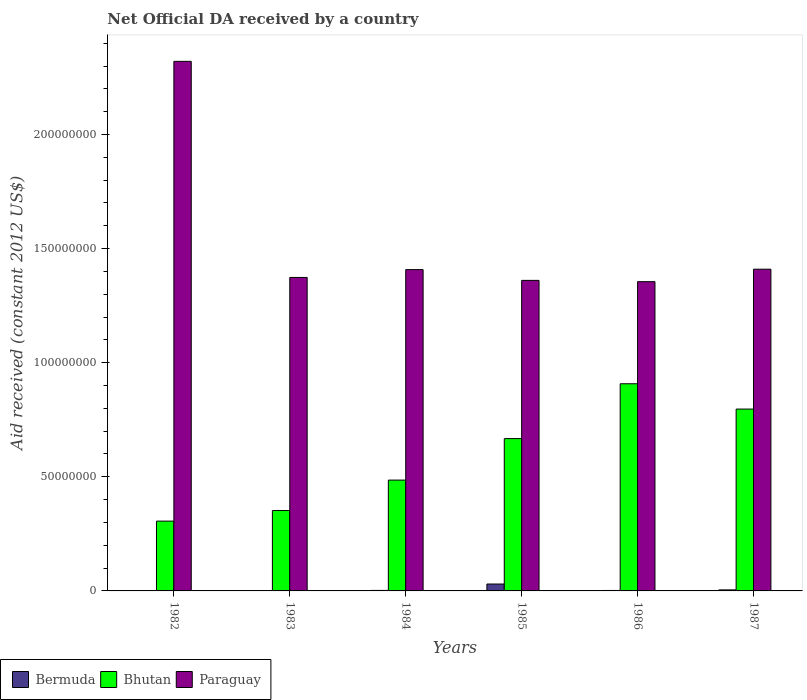How many different coloured bars are there?
Offer a very short reply. 3. How many groups of bars are there?
Provide a short and direct response. 6. Are the number of bars on each tick of the X-axis equal?
Offer a terse response. Yes. In how many cases, is the number of bars for a given year not equal to the number of legend labels?
Give a very brief answer. 0. What is the net official development assistance aid received in Paraguay in 1987?
Give a very brief answer. 1.41e+08. Across all years, what is the maximum net official development assistance aid received in Bermuda?
Offer a terse response. 3.02e+06. In which year was the net official development assistance aid received in Bermuda minimum?
Keep it short and to the point. 1982. What is the total net official development assistance aid received in Bermuda in the graph?
Provide a short and direct response. 4.25e+06. What is the difference between the net official development assistance aid received in Bhutan in 1983 and that in 1985?
Provide a succinct answer. -3.15e+07. What is the difference between the net official development assistance aid received in Bermuda in 1987 and the net official development assistance aid received in Bhutan in 1984?
Offer a terse response. -4.81e+07. What is the average net official development assistance aid received in Bermuda per year?
Offer a terse response. 7.08e+05. In the year 1984, what is the difference between the net official development assistance aid received in Bermuda and net official development assistance aid received in Bhutan?
Your response must be concise. -4.83e+07. What is the ratio of the net official development assistance aid received in Paraguay in 1983 to that in 1985?
Keep it short and to the point. 1.01. Is the net official development assistance aid received in Bhutan in 1982 less than that in 1987?
Ensure brevity in your answer.  Yes. Is the difference between the net official development assistance aid received in Bermuda in 1982 and 1985 greater than the difference between the net official development assistance aid received in Bhutan in 1982 and 1985?
Offer a very short reply. Yes. What is the difference between the highest and the second highest net official development assistance aid received in Bermuda?
Provide a short and direct response. 2.57e+06. What is the difference between the highest and the lowest net official development assistance aid received in Paraguay?
Offer a terse response. 9.65e+07. In how many years, is the net official development assistance aid received in Bhutan greater than the average net official development assistance aid received in Bhutan taken over all years?
Make the answer very short. 3. Is the sum of the net official development assistance aid received in Bhutan in 1985 and 1986 greater than the maximum net official development assistance aid received in Bermuda across all years?
Offer a very short reply. Yes. What does the 3rd bar from the left in 1982 represents?
Offer a terse response. Paraguay. What does the 2nd bar from the right in 1986 represents?
Keep it short and to the point. Bhutan. Are all the bars in the graph horizontal?
Your answer should be very brief. No. What is the difference between two consecutive major ticks on the Y-axis?
Ensure brevity in your answer.  5.00e+07. Does the graph contain grids?
Provide a short and direct response. No. How many legend labels are there?
Give a very brief answer. 3. How are the legend labels stacked?
Provide a succinct answer. Horizontal. What is the title of the graph?
Keep it short and to the point. Net Official DA received by a country. What is the label or title of the X-axis?
Provide a short and direct response. Years. What is the label or title of the Y-axis?
Ensure brevity in your answer.  Aid received (constant 2012 US$). What is the Aid received (constant 2012 US$) of Bermuda in 1982?
Keep it short and to the point. 1.80e+05. What is the Aid received (constant 2012 US$) in Bhutan in 1982?
Make the answer very short. 3.06e+07. What is the Aid received (constant 2012 US$) of Paraguay in 1982?
Your answer should be very brief. 2.32e+08. What is the Aid received (constant 2012 US$) of Bermuda in 1983?
Your answer should be very brief. 1.80e+05. What is the Aid received (constant 2012 US$) in Bhutan in 1983?
Your response must be concise. 3.52e+07. What is the Aid received (constant 2012 US$) in Paraguay in 1983?
Ensure brevity in your answer.  1.37e+08. What is the Aid received (constant 2012 US$) in Bhutan in 1984?
Offer a terse response. 4.86e+07. What is the Aid received (constant 2012 US$) in Paraguay in 1984?
Keep it short and to the point. 1.41e+08. What is the Aid received (constant 2012 US$) of Bermuda in 1985?
Your answer should be very brief. 3.02e+06. What is the Aid received (constant 2012 US$) in Bhutan in 1985?
Provide a succinct answer. 6.68e+07. What is the Aid received (constant 2012 US$) of Paraguay in 1985?
Give a very brief answer. 1.36e+08. What is the Aid received (constant 2012 US$) of Bermuda in 1986?
Ensure brevity in your answer.  2.00e+05. What is the Aid received (constant 2012 US$) of Bhutan in 1986?
Provide a short and direct response. 9.08e+07. What is the Aid received (constant 2012 US$) in Paraguay in 1986?
Provide a short and direct response. 1.36e+08. What is the Aid received (constant 2012 US$) in Bermuda in 1987?
Your answer should be very brief. 4.50e+05. What is the Aid received (constant 2012 US$) in Bhutan in 1987?
Offer a very short reply. 7.97e+07. What is the Aid received (constant 2012 US$) of Paraguay in 1987?
Give a very brief answer. 1.41e+08. Across all years, what is the maximum Aid received (constant 2012 US$) in Bermuda?
Your answer should be compact. 3.02e+06. Across all years, what is the maximum Aid received (constant 2012 US$) of Bhutan?
Make the answer very short. 9.08e+07. Across all years, what is the maximum Aid received (constant 2012 US$) in Paraguay?
Offer a terse response. 2.32e+08. Across all years, what is the minimum Aid received (constant 2012 US$) of Bermuda?
Your answer should be very brief. 1.80e+05. Across all years, what is the minimum Aid received (constant 2012 US$) in Bhutan?
Your answer should be very brief. 3.06e+07. Across all years, what is the minimum Aid received (constant 2012 US$) of Paraguay?
Your answer should be very brief. 1.36e+08. What is the total Aid received (constant 2012 US$) in Bermuda in the graph?
Your response must be concise. 4.25e+06. What is the total Aid received (constant 2012 US$) in Bhutan in the graph?
Your answer should be compact. 3.52e+08. What is the total Aid received (constant 2012 US$) in Paraguay in the graph?
Provide a short and direct response. 9.23e+08. What is the difference between the Aid received (constant 2012 US$) of Bermuda in 1982 and that in 1983?
Give a very brief answer. 0. What is the difference between the Aid received (constant 2012 US$) in Bhutan in 1982 and that in 1983?
Provide a short and direct response. -4.64e+06. What is the difference between the Aid received (constant 2012 US$) in Paraguay in 1982 and that in 1983?
Keep it short and to the point. 9.47e+07. What is the difference between the Aid received (constant 2012 US$) of Bhutan in 1982 and that in 1984?
Make the answer very short. -1.80e+07. What is the difference between the Aid received (constant 2012 US$) in Paraguay in 1982 and that in 1984?
Your response must be concise. 9.13e+07. What is the difference between the Aid received (constant 2012 US$) of Bermuda in 1982 and that in 1985?
Your response must be concise. -2.84e+06. What is the difference between the Aid received (constant 2012 US$) in Bhutan in 1982 and that in 1985?
Provide a short and direct response. -3.62e+07. What is the difference between the Aid received (constant 2012 US$) of Paraguay in 1982 and that in 1985?
Provide a short and direct response. 9.60e+07. What is the difference between the Aid received (constant 2012 US$) of Bermuda in 1982 and that in 1986?
Your response must be concise. -2.00e+04. What is the difference between the Aid received (constant 2012 US$) in Bhutan in 1982 and that in 1986?
Your answer should be very brief. -6.02e+07. What is the difference between the Aid received (constant 2012 US$) in Paraguay in 1982 and that in 1986?
Make the answer very short. 9.65e+07. What is the difference between the Aid received (constant 2012 US$) of Bhutan in 1982 and that in 1987?
Provide a succinct answer. -4.91e+07. What is the difference between the Aid received (constant 2012 US$) in Paraguay in 1982 and that in 1987?
Provide a succinct answer. 9.11e+07. What is the difference between the Aid received (constant 2012 US$) in Bhutan in 1983 and that in 1984?
Keep it short and to the point. -1.33e+07. What is the difference between the Aid received (constant 2012 US$) in Paraguay in 1983 and that in 1984?
Your answer should be very brief. -3.43e+06. What is the difference between the Aid received (constant 2012 US$) in Bermuda in 1983 and that in 1985?
Your response must be concise. -2.84e+06. What is the difference between the Aid received (constant 2012 US$) in Bhutan in 1983 and that in 1985?
Provide a succinct answer. -3.15e+07. What is the difference between the Aid received (constant 2012 US$) in Paraguay in 1983 and that in 1985?
Give a very brief answer. 1.29e+06. What is the difference between the Aid received (constant 2012 US$) in Bhutan in 1983 and that in 1986?
Provide a short and direct response. -5.56e+07. What is the difference between the Aid received (constant 2012 US$) of Paraguay in 1983 and that in 1986?
Your answer should be compact. 1.85e+06. What is the difference between the Aid received (constant 2012 US$) of Bermuda in 1983 and that in 1987?
Offer a terse response. -2.70e+05. What is the difference between the Aid received (constant 2012 US$) in Bhutan in 1983 and that in 1987?
Provide a short and direct response. -4.45e+07. What is the difference between the Aid received (constant 2012 US$) of Paraguay in 1983 and that in 1987?
Your answer should be very brief. -3.61e+06. What is the difference between the Aid received (constant 2012 US$) in Bermuda in 1984 and that in 1985?
Give a very brief answer. -2.80e+06. What is the difference between the Aid received (constant 2012 US$) in Bhutan in 1984 and that in 1985?
Ensure brevity in your answer.  -1.82e+07. What is the difference between the Aid received (constant 2012 US$) in Paraguay in 1984 and that in 1985?
Provide a succinct answer. 4.72e+06. What is the difference between the Aid received (constant 2012 US$) of Bhutan in 1984 and that in 1986?
Your answer should be compact. -4.22e+07. What is the difference between the Aid received (constant 2012 US$) in Paraguay in 1984 and that in 1986?
Provide a succinct answer. 5.28e+06. What is the difference between the Aid received (constant 2012 US$) of Bhutan in 1984 and that in 1987?
Offer a very short reply. -3.11e+07. What is the difference between the Aid received (constant 2012 US$) in Bermuda in 1985 and that in 1986?
Give a very brief answer. 2.82e+06. What is the difference between the Aid received (constant 2012 US$) in Bhutan in 1985 and that in 1986?
Make the answer very short. -2.40e+07. What is the difference between the Aid received (constant 2012 US$) in Paraguay in 1985 and that in 1986?
Your response must be concise. 5.60e+05. What is the difference between the Aid received (constant 2012 US$) in Bermuda in 1985 and that in 1987?
Offer a terse response. 2.57e+06. What is the difference between the Aid received (constant 2012 US$) of Bhutan in 1985 and that in 1987?
Ensure brevity in your answer.  -1.29e+07. What is the difference between the Aid received (constant 2012 US$) of Paraguay in 1985 and that in 1987?
Your answer should be compact. -4.90e+06. What is the difference between the Aid received (constant 2012 US$) in Bhutan in 1986 and that in 1987?
Give a very brief answer. 1.11e+07. What is the difference between the Aid received (constant 2012 US$) of Paraguay in 1986 and that in 1987?
Offer a terse response. -5.46e+06. What is the difference between the Aid received (constant 2012 US$) in Bermuda in 1982 and the Aid received (constant 2012 US$) in Bhutan in 1983?
Offer a terse response. -3.50e+07. What is the difference between the Aid received (constant 2012 US$) of Bermuda in 1982 and the Aid received (constant 2012 US$) of Paraguay in 1983?
Your answer should be very brief. -1.37e+08. What is the difference between the Aid received (constant 2012 US$) of Bhutan in 1982 and the Aid received (constant 2012 US$) of Paraguay in 1983?
Provide a short and direct response. -1.07e+08. What is the difference between the Aid received (constant 2012 US$) in Bermuda in 1982 and the Aid received (constant 2012 US$) in Bhutan in 1984?
Your answer should be very brief. -4.84e+07. What is the difference between the Aid received (constant 2012 US$) in Bermuda in 1982 and the Aid received (constant 2012 US$) in Paraguay in 1984?
Your answer should be compact. -1.41e+08. What is the difference between the Aid received (constant 2012 US$) in Bhutan in 1982 and the Aid received (constant 2012 US$) in Paraguay in 1984?
Your answer should be very brief. -1.10e+08. What is the difference between the Aid received (constant 2012 US$) of Bermuda in 1982 and the Aid received (constant 2012 US$) of Bhutan in 1985?
Offer a terse response. -6.66e+07. What is the difference between the Aid received (constant 2012 US$) of Bermuda in 1982 and the Aid received (constant 2012 US$) of Paraguay in 1985?
Your response must be concise. -1.36e+08. What is the difference between the Aid received (constant 2012 US$) in Bhutan in 1982 and the Aid received (constant 2012 US$) in Paraguay in 1985?
Offer a very short reply. -1.05e+08. What is the difference between the Aid received (constant 2012 US$) in Bermuda in 1982 and the Aid received (constant 2012 US$) in Bhutan in 1986?
Keep it short and to the point. -9.06e+07. What is the difference between the Aid received (constant 2012 US$) in Bermuda in 1982 and the Aid received (constant 2012 US$) in Paraguay in 1986?
Your response must be concise. -1.35e+08. What is the difference between the Aid received (constant 2012 US$) of Bhutan in 1982 and the Aid received (constant 2012 US$) of Paraguay in 1986?
Your response must be concise. -1.05e+08. What is the difference between the Aid received (constant 2012 US$) in Bermuda in 1982 and the Aid received (constant 2012 US$) in Bhutan in 1987?
Provide a short and direct response. -7.95e+07. What is the difference between the Aid received (constant 2012 US$) in Bermuda in 1982 and the Aid received (constant 2012 US$) in Paraguay in 1987?
Ensure brevity in your answer.  -1.41e+08. What is the difference between the Aid received (constant 2012 US$) of Bhutan in 1982 and the Aid received (constant 2012 US$) of Paraguay in 1987?
Make the answer very short. -1.10e+08. What is the difference between the Aid received (constant 2012 US$) in Bermuda in 1983 and the Aid received (constant 2012 US$) in Bhutan in 1984?
Provide a succinct answer. -4.84e+07. What is the difference between the Aid received (constant 2012 US$) in Bermuda in 1983 and the Aid received (constant 2012 US$) in Paraguay in 1984?
Ensure brevity in your answer.  -1.41e+08. What is the difference between the Aid received (constant 2012 US$) of Bhutan in 1983 and the Aid received (constant 2012 US$) of Paraguay in 1984?
Make the answer very short. -1.06e+08. What is the difference between the Aid received (constant 2012 US$) of Bermuda in 1983 and the Aid received (constant 2012 US$) of Bhutan in 1985?
Offer a terse response. -6.66e+07. What is the difference between the Aid received (constant 2012 US$) of Bermuda in 1983 and the Aid received (constant 2012 US$) of Paraguay in 1985?
Your answer should be compact. -1.36e+08. What is the difference between the Aid received (constant 2012 US$) in Bhutan in 1983 and the Aid received (constant 2012 US$) in Paraguay in 1985?
Provide a succinct answer. -1.01e+08. What is the difference between the Aid received (constant 2012 US$) in Bermuda in 1983 and the Aid received (constant 2012 US$) in Bhutan in 1986?
Give a very brief answer. -9.06e+07. What is the difference between the Aid received (constant 2012 US$) of Bermuda in 1983 and the Aid received (constant 2012 US$) of Paraguay in 1986?
Keep it short and to the point. -1.35e+08. What is the difference between the Aid received (constant 2012 US$) in Bhutan in 1983 and the Aid received (constant 2012 US$) in Paraguay in 1986?
Keep it short and to the point. -1.00e+08. What is the difference between the Aid received (constant 2012 US$) in Bermuda in 1983 and the Aid received (constant 2012 US$) in Bhutan in 1987?
Your answer should be very brief. -7.95e+07. What is the difference between the Aid received (constant 2012 US$) in Bermuda in 1983 and the Aid received (constant 2012 US$) in Paraguay in 1987?
Provide a succinct answer. -1.41e+08. What is the difference between the Aid received (constant 2012 US$) of Bhutan in 1983 and the Aid received (constant 2012 US$) of Paraguay in 1987?
Your response must be concise. -1.06e+08. What is the difference between the Aid received (constant 2012 US$) of Bermuda in 1984 and the Aid received (constant 2012 US$) of Bhutan in 1985?
Your response must be concise. -6.65e+07. What is the difference between the Aid received (constant 2012 US$) in Bermuda in 1984 and the Aid received (constant 2012 US$) in Paraguay in 1985?
Offer a terse response. -1.36e+08. What is the difference between the Aid received (constant 2012 US$) of Bhutan in 1984 and the Aid received (constant 2012 US$) of Paraguay in 1985?
Offer a terse response. -8.75e+07. What is the difference between the Aid received (constant 2012 US$) in Bermuda in 1984 and the Aid received (constant 2012 US$) in Bhutan in 1986?
Offer a terse response. -9.06e+07. What is the difference between the Aid received (constant 2012 US$) of Bermuda in 1984 and the Aid received (constant 2012 US$) of Paraguay in 1986?
Your answer should be compact. -1.35e+08. What is the difference between the Aid received (constant 2012 US$) in Bhutan in 1984 and the Aid received (constant 2012 US$) in Paraguay in 1986?
Your answer should be very brief. -8.70e+07. What is the difference between the Aid received (constant 2012 US$) of Bermuda in 1984 and the Aid received (constant 2012 US$) of Bhutan in 1987?
Offer a terse response. -7.95e+07. What is the difference between the Aid received (constant 2012 US$) of Bermuda in 1984 and the Aid received (constant 2012 US$) of Paraguay in 1987?
Provide a short and direct response. -1.41e+08. What is the difference between the Aid received (constant 2012 US$) of Bhutan in 1984 and the Aid received (constant 2012 US$) of Paraguay in 1987?
Your answer should be very brief. -9.24e+07. What is the difference between the Aid received (constant 2012 US$) in Bermuda in 1985 and the Aid received (constant 2012 US$) in Bhutan in 1986?
Make the answer very short. -8.78e+07. What is the difference between the Aid received (constant 2012 US$) of Bermuda in 1985 and the Aid received (constant 2012 US$) of Paraguay in 1986?
Ensure brevity in your answer.  -1.32e+08. What is the difference between the Aid received (constant 2012 US$) of Bhutan in 1985 and the Aid received (constant 2012 US$) of Paraguay in 1986?
Provide a succinct answer. -6.88e+07. What is the difference between the Aid received (constant 2012 US$) in Bermuda in 1985 and the Aid received (constant 2012 US$) in Bhutan in 1987?
Keep it short and to the point. -7.67e+07. What is the difference between the Aid received (constant 2012 US$) in Bermuda in 1985 and the Aid received (constant 2012 US$) in Paraguay in 1987?
Ensure brevity in your answer.  -1.38e+08. What is the difference between the Aid received (constant 2012 US$) of Bhutan in 1985 and the Aid received (constant 2012 US$) of Paraguay in 1987?
Provide a short and direct response. -7.42e+07. What is the difference between the Aid received (constant 2012 US$) in Bermuda in 1986 and the Aid received (constant 2012 US$) in Bhutan in 1987?
Provide a succinct answer. -7.95e+07. What is the difference between the Aid received (constant 2012 US$) of Bermuda in 1986 and the Aid received (constant 2012 US$) of Paraguay in 1987?
Your answer should be very brief. -1.41e+08. What is the difference between the Aid received (constant 2012 US$) of Bhutan in 1986 and the Aid received (constant 2012 US$) of Paraguay in 1987?
Keep it short and to the point. -5.02e+07. What is the average Aid received (constant 2012 US$) of Bermuda per year?
Your answer should be very brief. 7.08e+05. What is the average Aid received (constant 2012 US$) of Bhutan per year?
Your answer should be very brief. 5.86e+07. What is the average Aid received (constant 2012 US$) in Paraguay per year?
Offer a terse response. 1.54e+08. In the year 1982, what is the difference between the Aid received (constant 2012 US$) in Bermuda and Aid received (constant 2012 US$) in Bhutan?
Give a very brief answer. -3.04e+07. In the year 1982, what is the difference between the Aid received (constant 2012 US$) of Bermuda and Aid received (constant 2012 US$) of Paraguay?
Your answer should be compact. -2.32e+08. In the year 1982, what is the difference between the Aid received (constant 2012 US$) in Bhutan and Aid received (constant 2012 US$) in Paraguay?
Provide a short and direct response. -2.01e+08. In the year 1983, what is the difference between the Aid received (constant 2012 US$) in Bermuda and Aid received (constant 2012 US$) in Bhutan?
Ensure brevity in your answer.  -3.50e+07. In the year 1983, what is the difference between the Aid received (constant 2012 US$) of Bermuda and Aid received (constant 2012 US$) of Paraguay?
Your answer should be compact. -1.37e+08. In the year 1983, what is the difference between the Aid received (constant 2012 US$) of Bhutan and Aid received (constant 2012 US$) of Paraguay?
Your answer should be very brief. -1.02e+08. In the year 1984, what is the difference between the Aid received (constant 2012 US$) in Bermuda and Aid received (constant 2012 US$) in Bhutan?
Offer a terse response. -4.83e+07. In the year 1984, what is the difference between the Aid received (constant 2012 US$) in Bermuda and Aid received (constant 2012 US$) in Paraguay?
Offer a terse response. -1.41e+08. In the year 1984, what is the difference between the Aid received (constant 2012 US$) of Bhutan and Aid received (constant 2012 US$) of Paraguay?
Provide a short and direct response. -9.22e+07. In the year 1985, what is the difference between the Aid received (constant 2012 US$) in Bermuda and Aid received (constant 2012 US$) in Bhutan?
Provide a short and direct response. -6.37e+07. In the year 1985, what is the difference between the Aid received (constant 2012 US$) of Bermuda and Aid received (constant 2012 US$) of Paraguay?
Keep it short and to the point. -1.33e+08. In the year 1985, what is the difference between the Aid received (constant 2012 US$) in Bhutan and Aid received (constant 2012 US$) in Paraguay?
Ensure brevity in your answer.  -6.93e+07. In the year 1986, what is the difference between the Aid received (constant 2012 US$) of Bermuda and Aid received (constant 2012 US$) of Bhutan?
Make the answer very short. -9.06e+07. In the year 1986, what is the difference between the Aid received (constant 2012 US$) in Bermuda and Aid received (constant 2012 US$) in Paraguay?
Make the answer very short. -1.35e+08. In the year 1986, what is the difference between the Aid received (constant 2012 US$) of Bhutan and Aid received (constant 2012 US$) of Paraguay?
Keep it short and to the point. -4.47e+07. In the year 1987, what is the difference between the Aid received (constant 2012 US$) in Bermuda and Aid received (constant 2012 US$) in Bhutan?
Provide a succinct answer. -7.92e+07. In the year 1987, what is the difference between the Aid received (constant 2012 US$) of Bermuda and Aid received (constant 2012 US$) of Paraguay?
Your response must be concise. -1.41e+08. In the year 1987, what is the difference between the Aid received (constant 2012 US$) in Bhutan and Aid received (constant 2012 US$) in Paraguay?
Give a very brief answer. -6.13e+07. What is the ratio of the Aid received (constant 2012 US$) in Bhutan in 1982 to that in 1983?
Offer a terse response. 0.87. What is the ratio of the Aid received (constant 2012 US$) in Paraguay in 1982 to that in 1983?
Make the answer very short. 1.69. What is the ratio of the Aid received (constant 2012 US$) in Bermuda in 1982 to that in 1984?
Give a very brief answer. 0.82. What is the ratio of the Aid received (constant 2012 US$) in Bhutan in 1982 to that in 1984?
Give a very brief answer. 0.63. What is the ratio of the Aid received (constant 2012 US$) of Paraguay in 1982 to that in 1984?
Your response must be concise. 1.65. What is the ratio of the Aid received (constant 2012 US$) of Bermuda in 1982 to that in 1985?
Your answer should be compact. 0.06. What is the ratio of the Aid received (constant 2012 US$) in Bhutan in 1982 to that in 1985?
Your answer should be compact. 0.46. What is the ratio of the Aid received (constant 2012 US$) in Paraguay in 1982 to that in 1985?
Offer a terse response. 1.71. What is the ratio of the Aid received (constant 2012 US$) of Bhutan in 1982 to that in 1986?
Keep it short and to the point. 0.34. What is the ratio of the Aid received (constant 2012 US$) of Paraguay in 1982 to that in 1986?
Your answer should be compact. 1.71. What is the ratio of the Aid received (constant 2012 US$) of Bermuda in 1982 to that in 1987?
Offer a very short reply. 0.4. What is the ratio of the Aid received (constant 2012 US$) of Bhutan in 1982 to that in 1987?
Keep it short and to the point. 0.38. What is the ratio of the Aid received (constant 2012 US$) of Paraguay in 1982 to that in 1987?
Offer a terse response. 1.65. What is the ratio of the Aid received (constant 2012 US$) of Bermuda in 1983 to that in 1984?
Make the answer very short. 0.82. What is the ratio of the Aid received (constant 2012 US$) in Bhutan in 1983 to that in 1984?
Your response must be concise. 0.73. What is the ratio of the Aid received (constant 2012 US$) of Paraguay in 1983 to that in 1984?
Your response must be concise. 0.98. What is the ratio of the Aid received (constant 2012 US$) in Bermuda in 1983 to that in 1985?
Keep it short and to the point. 0.06. What is the ratio of the Aid received (constant 2012 US$) in Bhutan in 1983 to that in 1985?
Ensure brevity in your answer.  0.53. What is the ratio of the Aid received (constant 2012 US$) in Paraguay in 1983 to that in 1985?
Offer a very short reply. 1.01. What is the ratio of the Aid received (constant 2012 US$) in Bhutan in 1983 to that in 1986?
Your answer should be very brief. 0.39. What is the ratio of the Aid received (constant 2012 US$) of Paraguay in 1983 to that in 1986?
Your response must be concise. 1.01. What is the ratio of the Aid received (constant 2012 US$) in Bhutan in 1983 to that in 1987?
Ensure brevity in your answer.  0.44. What is the ratio of the Aid received (constant 2012 US$) of Paraguay in 1983 to that in 1987?
Make the answer very short. 0.97. What is the ratio of the Aid received (constant 2012 US$) of Bermuda in 1984 to that in 1985?
Provide a short and direct response. 0.07. What is the ratio of the Aid received (constant 2012 US$) of Bhutan in 1984 to that in 1985?
Provide a short and direct response. 0.73. What is the ratio of the Aid received (constant 2012 US$) of Paraguay in 1984 to that in 1985?
Your answer should be very brief. 1.03. What is the ratio of the Aid received (constant 2012 US$) in Bermuda in 1984 to that in 1986?
Your answer should be compact. 1.1. What is the ratio of the Aid received (constant 2012 US$) in Bhutan in 1984 to that in 1986?
Keep it short and to the point. 0.53. What is the ratio of the Aid received (constant 2012 US$) in Paraguay in 1984 to that in 1986?
Provide a short and direct response. 1.04. What is the ratio of the Aid received (constant 2012 US$) in Bermuda in 1984 to that in 1987?
Your answer should be very brief. 0.49. What is the ratio of the Aid received (constant 2012 US$) in Bhutan in 1984 to that in 1987?
Keep it short and to the point. 0.61. What is the ratio of the Aid received (constant 2012 US$) of Bhutan in 1985 to that in 1986?
Provide a short and direct response. 0.74. What is the ratio of the Aid received (constant 2012 US$) in Paraguay in 1985 to that in 1986?
Make the answer very short. 1. What is the ratio of the Aid received (constant 2012 US$) of Bermuda in 1985 to that in 1987?
Provide a short and direct response. 6.71. What is the ratio of the Aid received (constant 2012 US$) in Bhutan in 1985 to that in 1987?
Make the answer very short. 0.84. What is the ratio of the Aid received (constant 2012 US$) of Paraguay in 1985 to that in 1987?
Make the answer very short. 0.97. What is the ratio of the Aid received (constant 2012 US$) of Bermuda in 1986 to that in 1987?
Your answer should be very brief. 0.44. What is the ratio of the Aid received (constant 2012 US$) of Bhutan in 1986 to that in 1987?
Offer a terse response. 1.14. What is the ratio of the Aid received (constant 2012 US$) of Paraguay in 1986 to that in 1987?
Provide a short and direct response. 0.96. What is the difference between the highest and the second highest Aid received (constant 2012 US$) of Bermuda?
Give a very brief answer. 2.57e+06. What is the difference between the highest and the second highest Aid received (constant 2012 US$) in Bhutan?
Your answer should be very brief. 1.11e+07. What is the difference between the highest and the second highest Aid received (constant 2012 US$) of Paraguay?
Provide a short and direct response. 9.11e+07. What is the difference between the highest and the lowest Aid received (constant 2012 US$) of Bermuda?
Make the answer very short. 2.84e+06. What is the difference between the highest and the lowest Aid received (constant 2012 US$) in Bhutan?
Keep it short and to the point. 6.02e+07. What is the difference between the highest and the lowest Aid received (constant 2012 US$) in Paraguay?
Make the answer very short. 9.65e+07. 